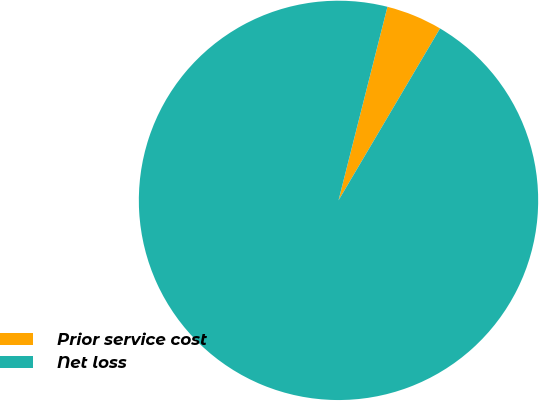Convert chart to OTSL. <chart><loc_0><loc_0><loc_500><loc_500><pie_chart><fcel>Prior service cost<fcel>Net loss<nl><fcel>4.55%<fcel>95.45%<nl></chart> 